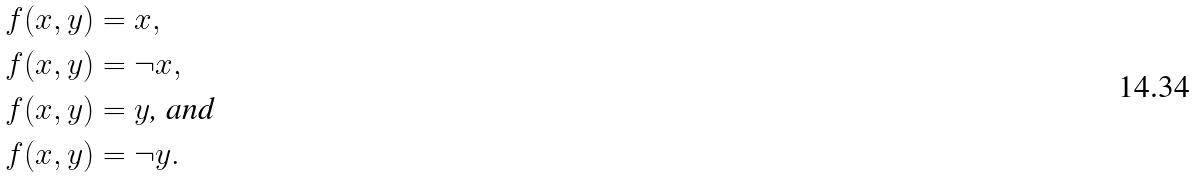<formula> <loc_0><loc_0><loc_500><loc_500>f ( x , y ) & = x , \\ f ( x , y ) & = \neg x , \\ f ( x , y ) & = y \text {, and} \\ f ( x , y ) & = \neg y .</formula> 